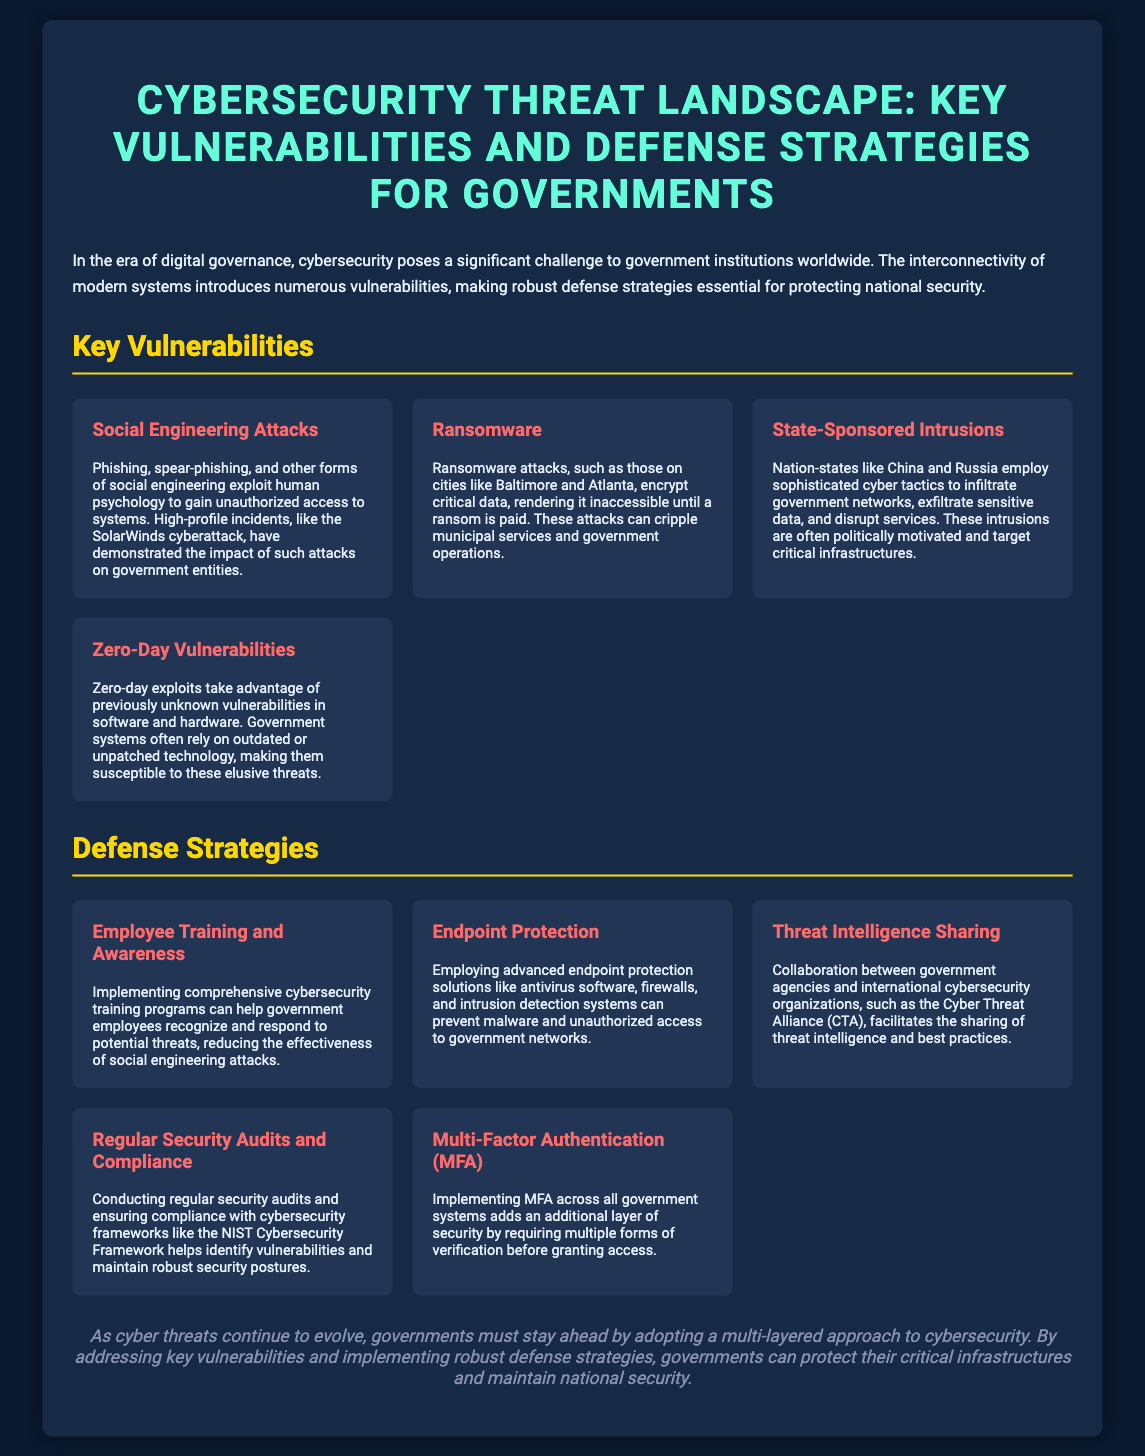What are social engineering attacks? Social engineering attacks exploit human psychology to gain unauthorized access to systems, including phishing and spear-phishing.
Answer: Exploit human psychology What is one of the cities affected by ransomware? The document mentions specific incidents where ransomware attacks occurred, including Baltimore and Atlanta.
Answer: Baltimore Which nations are known for state-sponsored intrusions? Nation-states that employ sophisticated cyber tactics include China and Russia, as mentioned in the document.
Answer: China and Russia What is a key defense strategy mentioned for reducing social engineering attacks? A defense strategy to reduce the effectiveness of social engineering attacks is implementing comprehensive cybersecurity training programs.
Answer: Employee training and awareness What additional security layer does Multi-Factor Authentication provide? Multi-Factor Authentication adds additional verification requirements for access, enhancing security.
Answer: Additional layer of security 